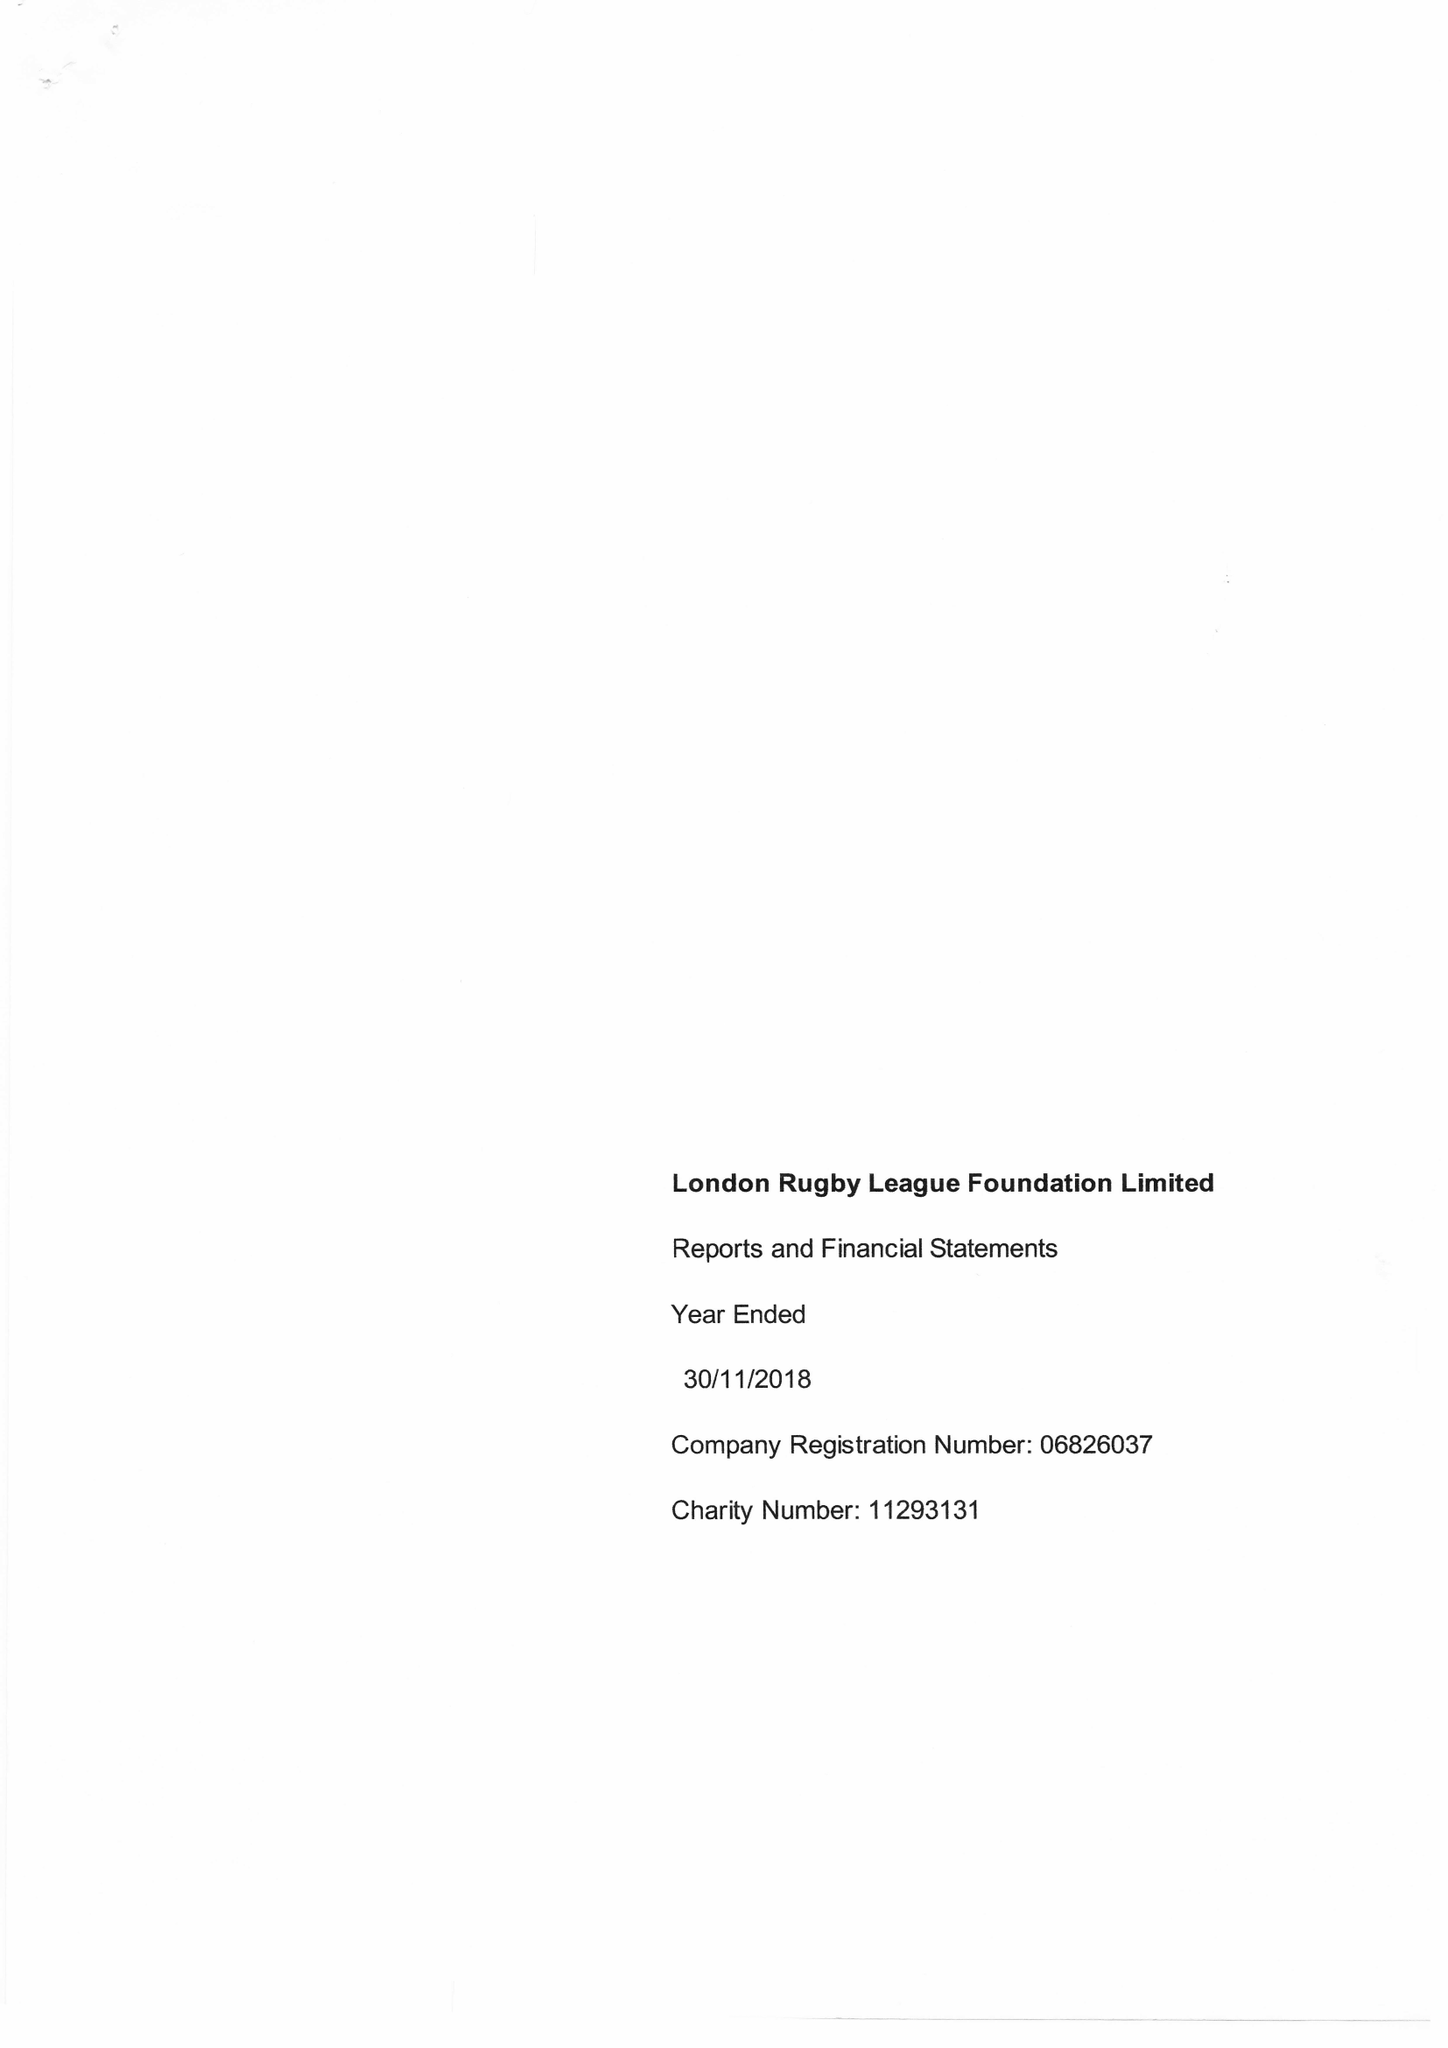What is the value for the address__postcode?
Answer the question using a single word or phrase. SE1 4YB 